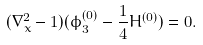<formula> <loc_0><loc_0><loc_500><loc_500>( \nabla _ { x } ^ { 2 } - 1 ) ( \phi _ { 3 } ^ { ( 0 ) } - \frac { 1 } { 4 } H ^ { ( 0 ) } ) = 0 .</formula> 